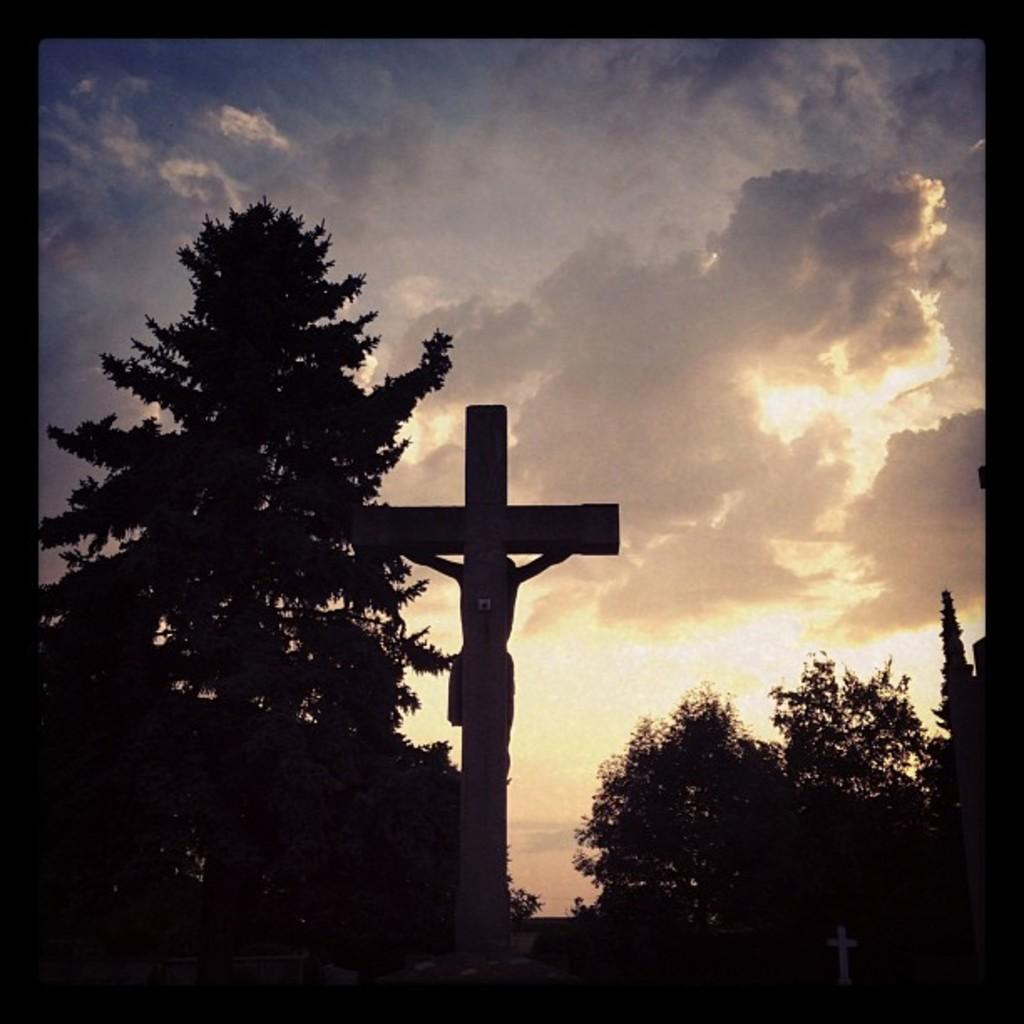What type of vegetation is visible in the image? There are trees in the image. What religious figure is depicted in the image? There is a statue of Jesus Christ in the image. What can be seen in the sky in the image? There are clouds in the sky in the image. What type of animal can be seen climbing the statue of Jesus Christ in the image? There is no animal present in the image, and the statue of Jesus Christ is not being climbed. Can you see a snake wrapped around the statue of Jesus Christ in the image? There is no snake present in the image, and the statue of Jesus Christ is not being climbed. 